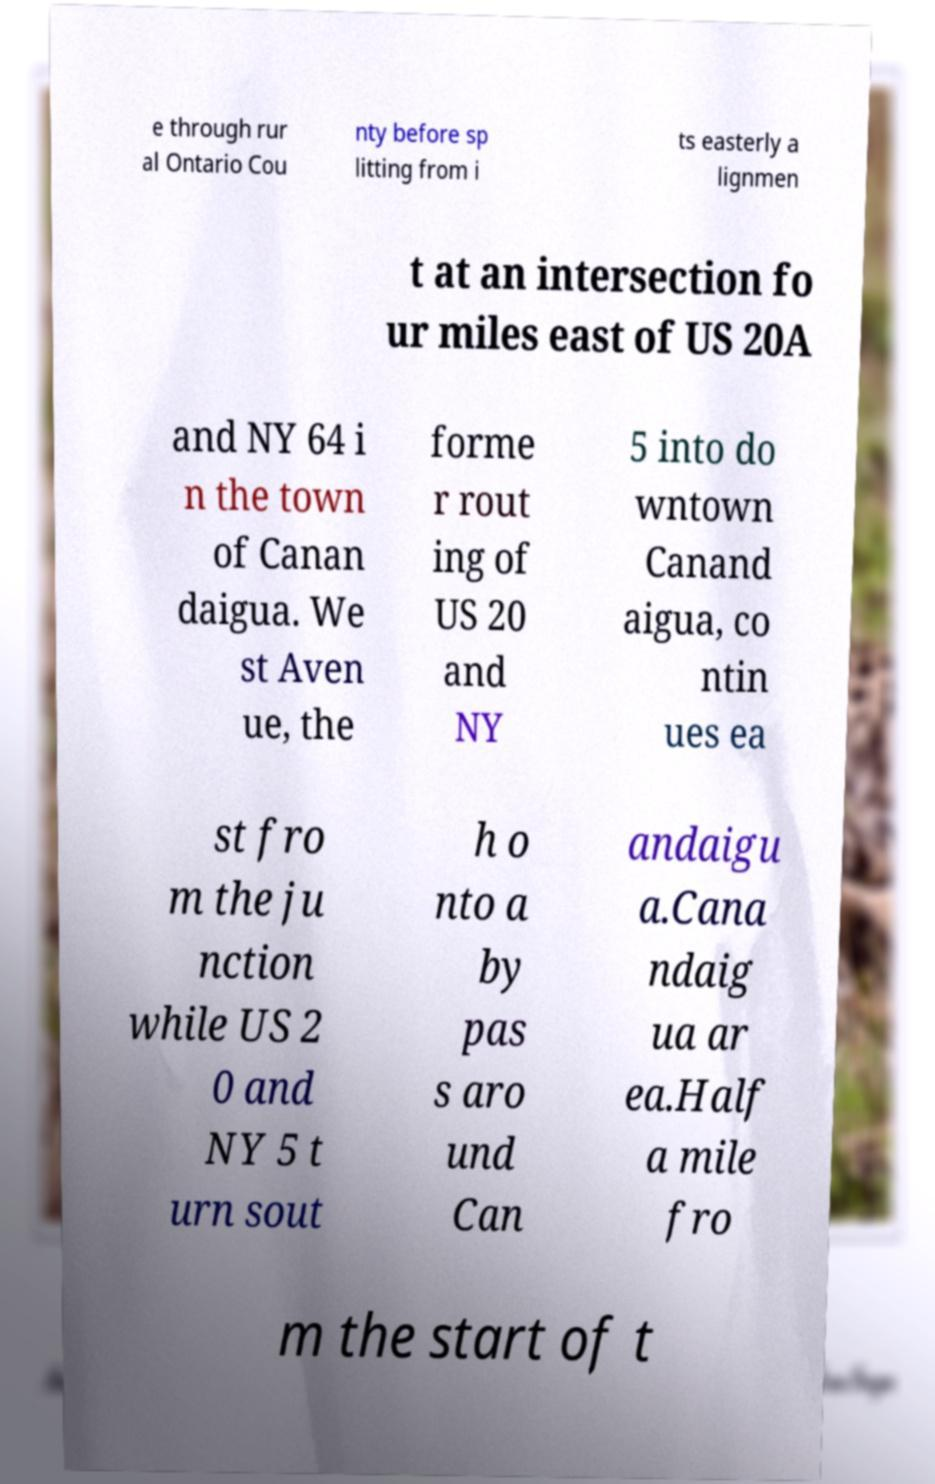Could you assist in decoding the text presented in this image and type it out clearly? e through rur al Ontario Cou nty before sp litting from i ts easterly a lignmen t at an intersection fo ur miles east of US 20A and NY 64 i n the town of Canan daigua. We st Aven ue, the forme r rout ing of US 20 and NY 5 into do wntown Canand aigua, co ntin ues ea st fro m the ju nction while US 2 0 and NY 5 t urn sout h o nto a by pas s aro und Can andaigu a.Cana ndaig ua ar ea.Half a mile fro m the start of t 